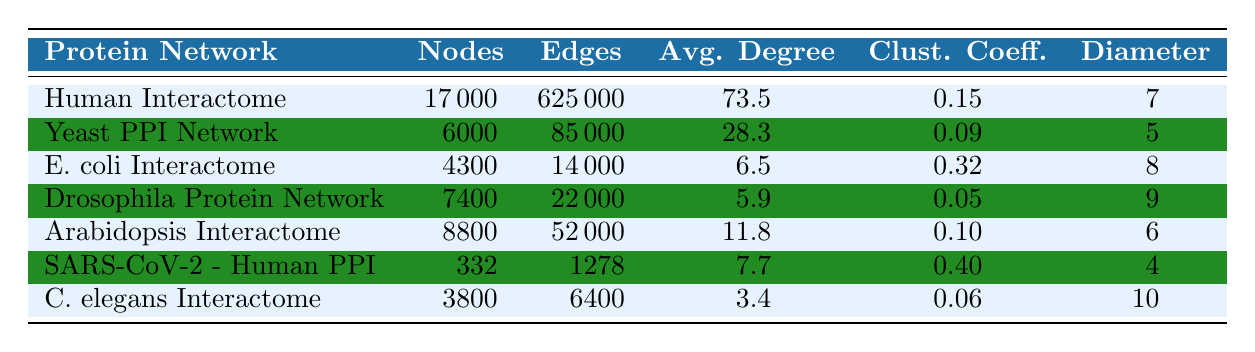What is the number of nodes in the Human Interactome? The table lists the Human Interactome under the "Protein Network" column. Referencing the corresponding value in the "Number of Nodes" column, it shows that there are 17000 nodes.
Answer: 17000 How many edges does the E. coli Interactome have? The E. coli Interactome is mentioned in the table. Looking at the "Number of Edges" column next to it, we find that it has 14000 edges.
Answer: 14000 What is the average degree of the Yeast PPI Network? The Yeast PPI Network is listed in the table. By checking the "Average Degree" column, we see it has an average degree of 28.3.
Answer: 28.3 Which protein network has the highest clustering coefficient? To find the highest clustering coefficient, we compare the values listed in the "Clustering Coefficient" column for all networks. The highest value is 0.40 for the SARS-CoV-2 - Human PPI network.
Answer: SARS-CoV-2 - Human PPI What is the total number of edges for all networks combined? We sum the edges in the "Number of Edges" column for all networks: 625000 + 85000 + 14000 + 22000 + 52000 + 1278 + 6400 = 799680. Thus, the total number of edges is 799680.
Answer: 799680 Is the average degree of Drosophila Protein Network greater than that of Arabidopsis Interactome? We need to compare the average degrees listed in the respective columns. Drosophila's average degree is 5.9 while Arabidopsis' is 11.8. Since 5.9 is less than 11.8, the answer is no.
Answer: No Does the C. elegans Interactome have more nodes than the E. coli Interactome? Checking the "Number of Nodes" column, C. elegans has 3800 nodes and E. coli has 4300 nodes. Since 3800 is less than 4300, the answer is no.
Answer: No What is the diameter of the protein network with the lowest average degree? First, we identify the average degrees from the "Average Degree" column. The C. elegans Interactome has the lowest average degree of 3.4. Checking the corresponding "Diameter" value for C. elegans, it is 10. Thus, the diameter is 10.
Answer: 10 Which network has the smallest diameter? To determine the smallest diameter, we compare the "Diameter" values across all networks. The smallest value is 4 for the SARS-CoV-2 - Human PPI.
Answer: SARS-CoV-2 - Human PPI 